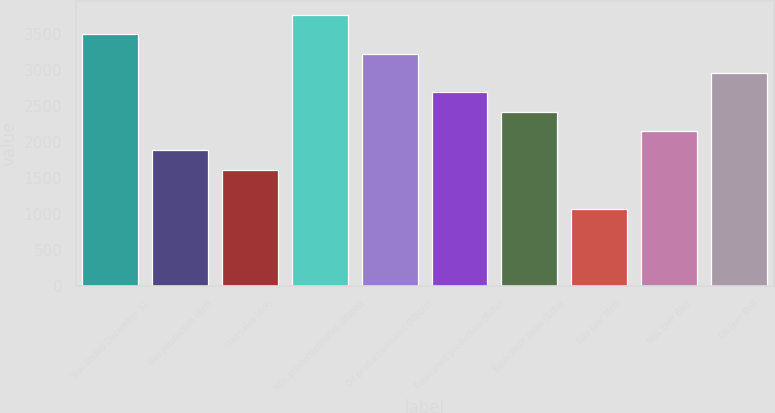Convert chart to OTSL. <chart><loc_0><loc_0><loc_500><loc_500><bar_chart><fcel>Year Ended December 31<fcel>Gas production (Bcf)<fcel>Gas sales (Bcf)<fcel>NGL production/sales (Mbbls)<fcel>Oil production/sales (Mbbls)<fcel>Equivalent production (Bcfe)<fcel>Equivalent sales (Bcfe)<fcel>Gas (per Mcf)<fcel>NGL (per Bbl)<fcel>Oil (per Bbl)<nl><fcel>3501.68<fcel>1885.7<fcel>1616.37<fcel>3771.01<fcel>3232.35<fcel>2693.69<fcel>2424.36<fcel>1077.71<fcel>2155.03<fcel>2963.02<nl></chart> 